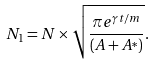<formula> <loc_0><loc_0><loc_500><loc_500>N _ { 1 } = N \times \sqrt { \frac { \pi e ^ { \gamma t / m } } { ( A + A ^ { * } ) } } .</formula> 